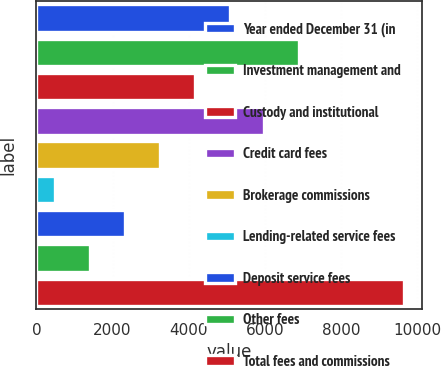Convert chart. <chart><loc_0><loc_0><loc_500><loc_500><bar_chart><fcel>Year ended December 31 (in<fcel>Investment management and<fcel>Custody and institutional<fcel>Credit card fees<fcel>Brokerage commissions<fcel>Lending-related service fees<fcel>Deposit service fees<fcel>Other fees<fcel>Total fees and commissions<nl><fcel>5075<fcel>6907<fcel>4159<fcel>5991<fcel>3243<fcel>495<fcel>2327<fcel>1411<fcel>9655<nl></chart> 